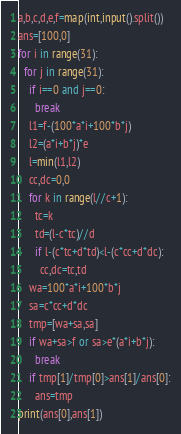<code> <loc_0><loc_0><loc_500><loc_500><_Python_>a,b,c,d,e,f=map(int,input().split())
ans=[100,0]
for i in range(31):
  for j in range(31):
    if i==0 and j==0:
      break
    l1=f-(100*a*i+100*b*j)
    l2=(a*i+b*j)*e
    l=min(l1,l2)
    cc,dc=0,0
    for k in range(l//c+1):
      tc=k
      td=(l-c*tc)//d
      if l-(c*tc+d*td)<l-(c*cc+d*dc):
        cc,dc=tc,td
    wa=100*a*i+100*b*j
    sa=c*cc+d*dc
    tmp=[wa+sa,sa]
    if wa+sa>f or sa>e*(a*i+b*j):
      break
    if tmp[1]/tmp[0]>ans[1]/ans[0]:
      ans=tmp
print(ans[0],ans[1])</code> 